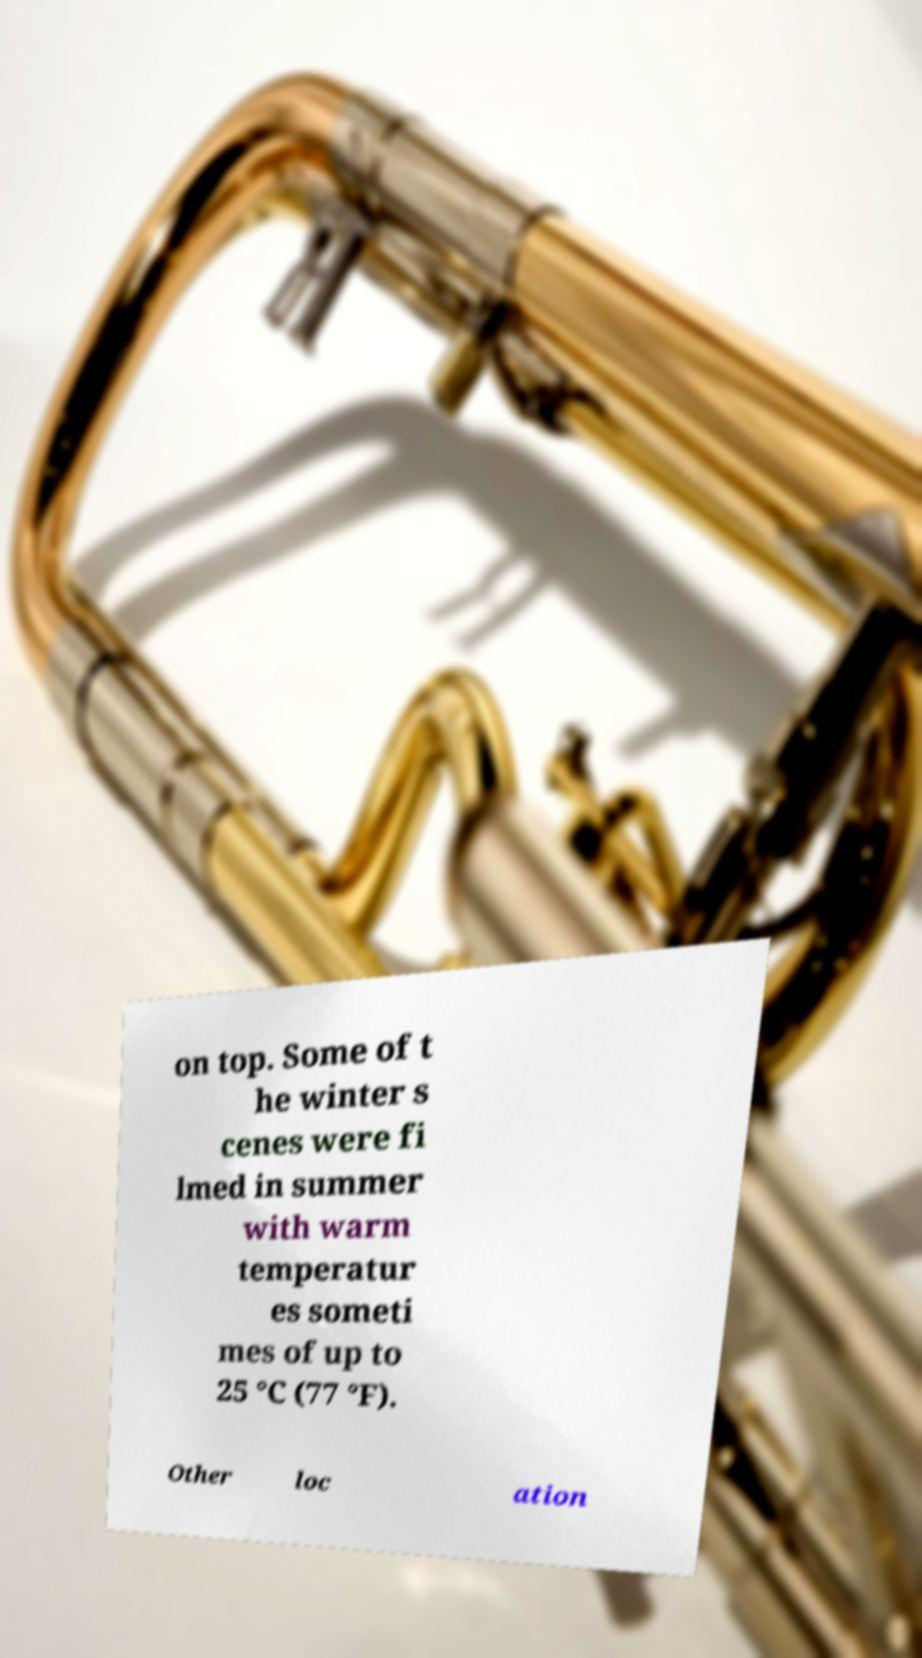Can you read and provide the text displayed in the image?This photo seems to have some interesting text. Can you extract and type it out for me? on top. Some of t he winter s cenes were fi lmed in summer with warm temperatur es someti mes of up to 25 °C (77 °F). Other loc ation 